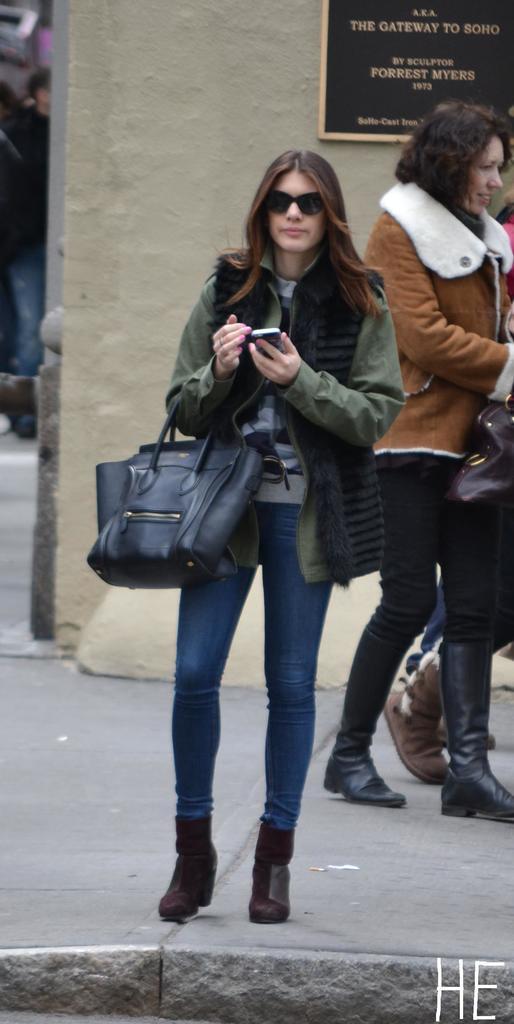Describe this image in one or two sentences. In this picture there is woman stood on the pavement. She wore boots,jacket,handbag, a cellphone in her hand. Behind her there is another woman with boots and jacket walking and on the background wall there is a board with some text. 